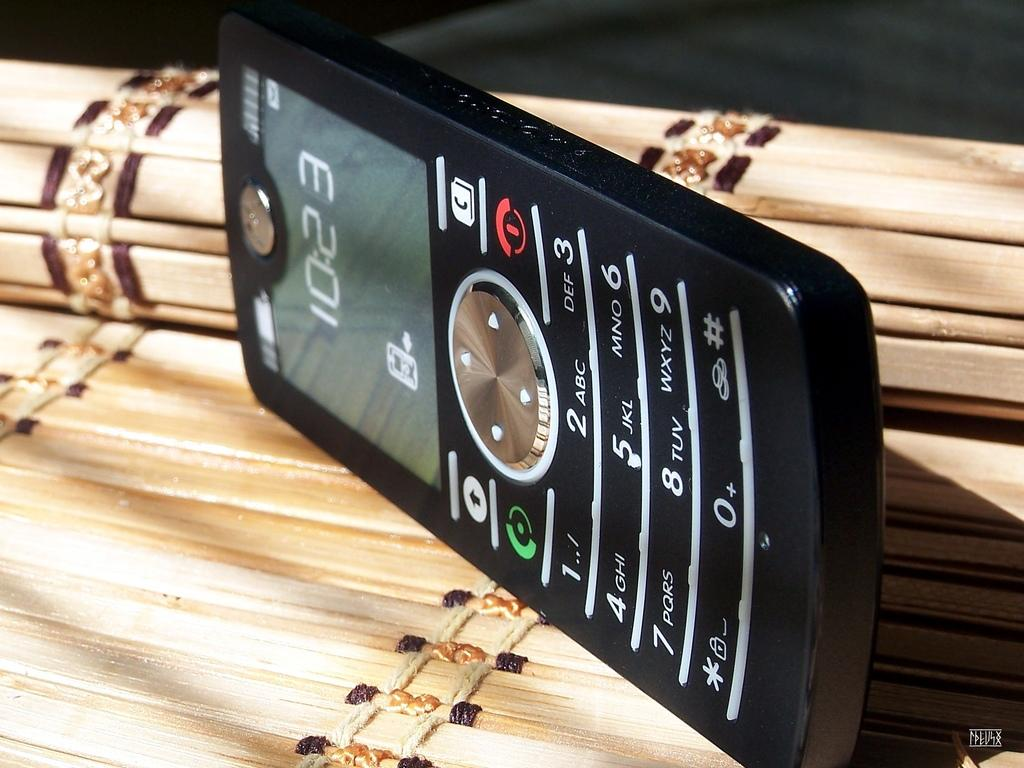<image>
Create a compact narrative representing the image presented. black phone on its side showing the time at 10:23 